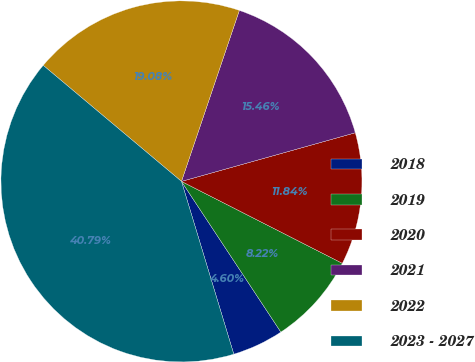Convert chart to OTSL. <chart><loc_0><loc_0><loc_500><loc_500><pie_chart><fcel>2018<fcel>2019<fcel>2020<fcel>2021<fcel>2022<fcel>2023 - 2027<nl><fcel>4.6%<fcel>8.22%<fcel>11.84%<fcel>15.46%<fcel>19.08%<fcel>40.79%<nl></chart> 